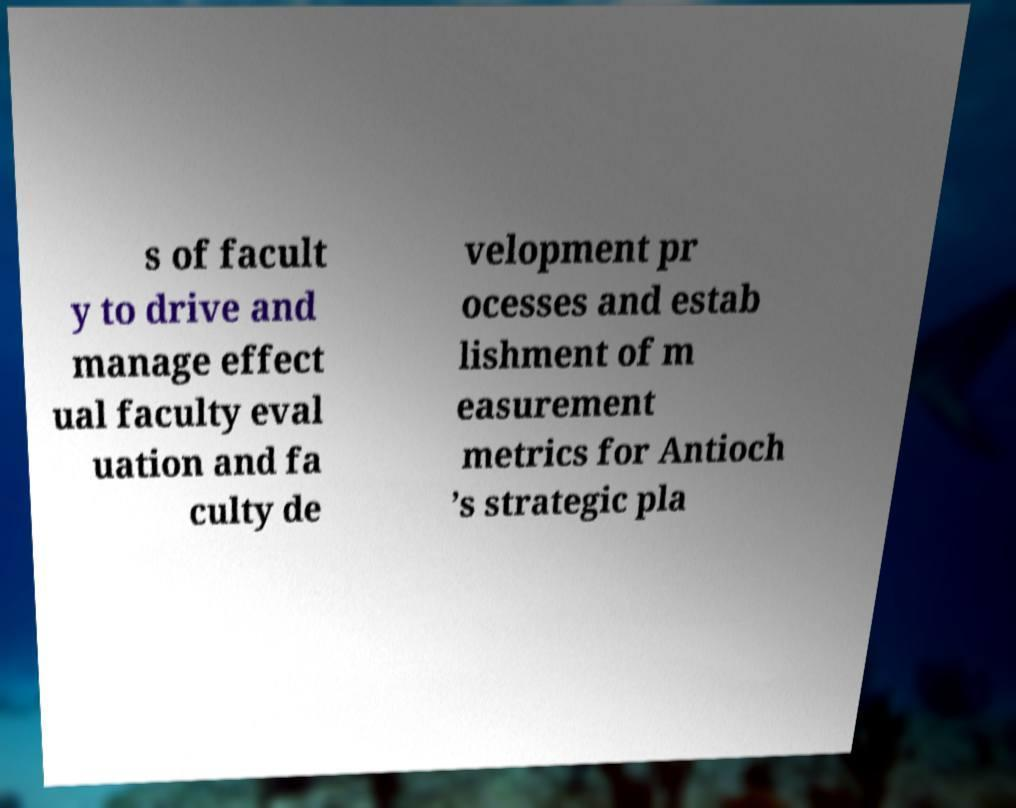Could you extract and type out the text from this image? s of facult y to drive and manage effect ual faculty eval uation and fa culty de velopment pr ocesses and estab lishment of m easurement metrics for Antioch ’s strategic pla 